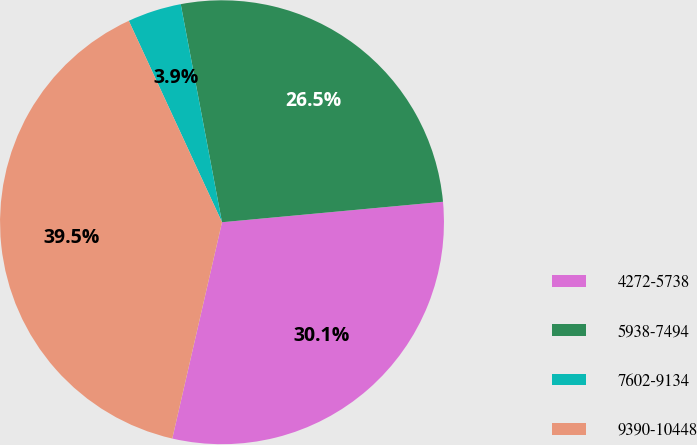<chart> <loc_0><loc_0><loc_500><loc_500><pie_chart><fcel>4272-5738<fcel>5938-7494<fcel>7602-9134<fcel>9390-10448<nl><fcel>30.07%<fcel>26.51%<fcel>3.92%<fcel>39.51%<nl></chart> 